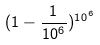<formula> <loc_0><loc_0><loc_500><loc_500>( 1 - \frac { 1 } { 1 0 ^ { 6 } } ) ^ { 1 0 ^ { 6 } }</formula> 